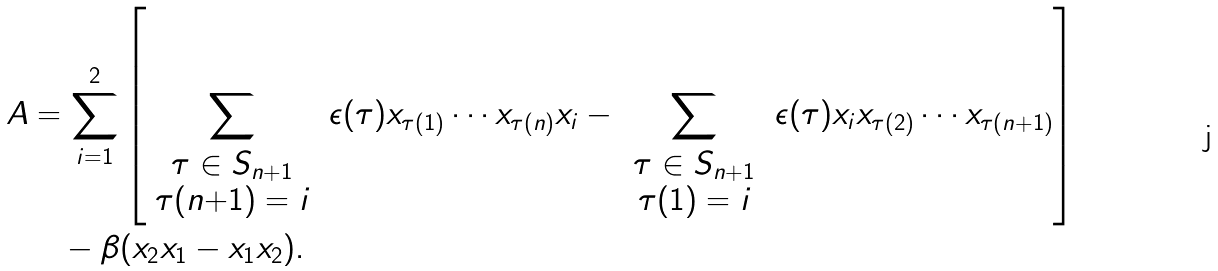Convert formula to latex. <formula><loc_0><loc_0><loc_500><loc_500>A & = \sum _ { i = 1 } ^ { 2 } \left [ \sum _ { \begin{array} { c } \tau \in S _ { n + 1 } \\ \tau ( n { + } 1 ) = i \end{array} } \, \epsilon ( \tau ) x _ { \tau ( 1 ) } \cdots x _ { \tau ( n ) } x _ { i } - \, \sum _ { \begin{array} { c } \tau \in S _ { n + 1 } \\ \tau ( 1 ) = i \end{array} } \, \epsilon ( \tau ) x _ { i } x _ { \tau ( 2 ) } \cdots x _ { \tau ( n + 1 ) } \right ] \\ & \quad - \beta ( x _ { 2 } x _ { 1 } - x _ { 1 } x _ { 2 } ) .</formula> 